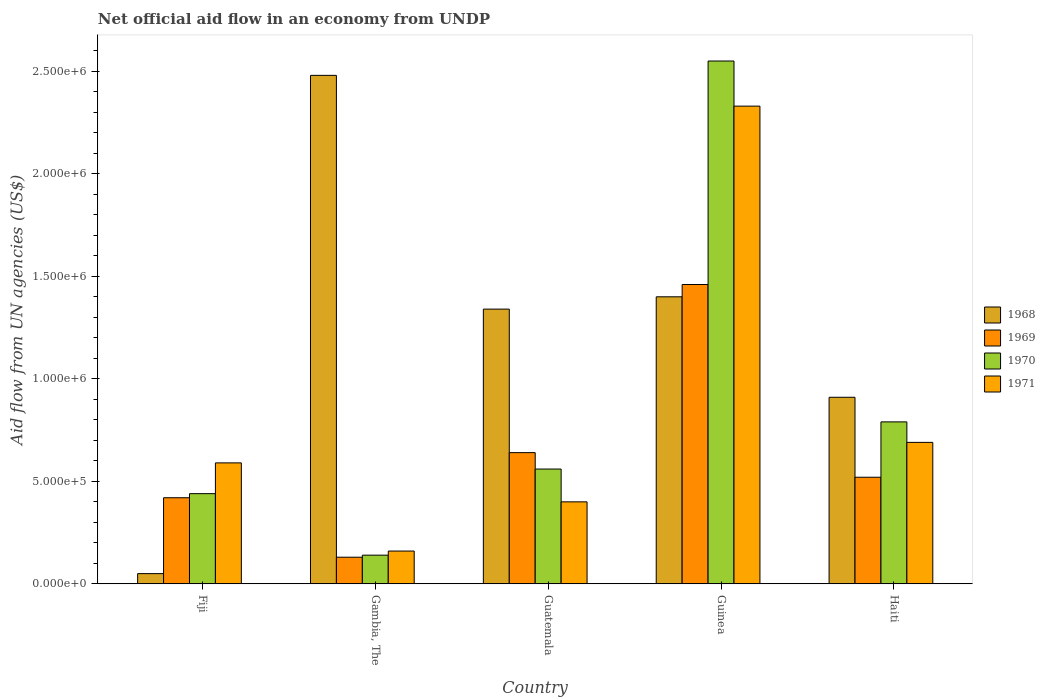How many different coloured bars are there?
Give a very brief answer. 4. How many groups of bars are there?
Provide a succinct answer. 5. Are the number of bars on each tick of the X-axis equal?
Your answer should be compact. Yes. What is the label of the 4th group of bars from the left?
Your response must be concise. Guinea. In how many cases, is the number of bars for a given country not equal to the number of legend labels?
Your answer should be compact. 0. What is the net official aid flow in 1969 in Haiti?
Provide a short and direct response. 5.20e+05. Across all countries, what is the maximum net official aid flow in 1969?
Your answer should be compact. 1.46e+06. Across all countries, what is the minimum net official aid flow in 1970?
Make the answer very short. 1.40e+05. In which country was the net official aid flow in 1971 maximum?
Your answer should be very brief. Guinea. In which country was the net official aid flow in 1970 minimum?
Provide a succinct answer. Gambia, The. What is the total net official aid flow in 1970 in the graph?
Give a very brief answer. 4.48e+06. What is the difference between the net official aid flow in 1971 in Fiji and that in Gambia, The?
Ensure brevity in your answer.  4.30e+05. What is the difference between the net official aid flow in 1970 in Guatemala and the net official aid flow in 1971 in Guinea?
Provide a short and direct response. -1.77e+06. What is the average net official aid flow in 1969 per country?
Your response must be concise. 6.34e+05. What is the difference between the net official aid flow of/in 1971 and net official aid flow of/in 1968 in Guinea?
Offer a very short reply. 9.30e+05. What is the ratio of the net official aid flow in 1971 in Gambia, The to that in Guatemala?
Provide a short and direct response. 0.4. What is the difference between the highest and the second highest net official aid flow in 1969?
Make the answer very short. 8.20e+05. What is the difference between the highest and the lowest net official aid flow in 1970?
Provide a short and direct response. 2.41e+06. Is the sum of the net official aid flow in 1968 in Guatemala and Haiti greater than the maximum net official aid flow in 1971 across all countries?
Give a very brief answer. No. What does the 3rd bar from the left in Guinea represents?
Your answer should be compact. 1970. What does the 4th bar from the right in Gambia, The represents?
Make the answer very short. 1968. Is it the case that in every country, the sum of the net official aid flow in 1969 and net official aid flow in 1971 is greater than the net official aid flow in 1970?
Offer a very short reply. Yes. How many bars are there?
Ensure brevity in your answer.  20. Are all the bars in the graph horizontal?
Your answer should be very brief. No. What is the difference between two consecutive major ticks on the Y-axis?
Offer a terse response. 5.00e+05. Are the values on the major ticks of Y-axis written in scientific E-notation?
Keep it short and to the point. Yes. Does the graph contain grids?
Your answer should be very brief. No. Where does the legend appear in the graph?
Make the answer very short. Center right. How many legend labels are there?
Ensure brevity in your answer.  4. How are the legend labels stacked?
Give a very brief answer. Vertical. What is the title of the graph?
Your answer should be very brief. Net official aid flow in an economy from UNDP. Does "1986" appear as one of the legend labels in the graph?
Make the answer very short. No. What is the label or title of the X-axis?
Your response must be concise. Country. What is the label or title of the Y-axis?
Keep it short and to the point. Aid flow from UN agencies (US$). What is the Aid flow from UN agencies (US$) in 1971 in Fiji?
Your answer should be very brief. 5.90e+05. What is the Aid flow from UN agencies (US$) in 1968 in Gambia, The?
Offer a very short reply. 2.48e+06. What is the Aid flow from UN agencies (US$) in 1969 in Gambia, The?
Ensure brevity in your answer.  1.30e+05. What is the Aid flow from UN agencies (US$) of 1968 in Guatemala?
Provide a short and direct response. 1.34e+06. What is the Aid flow from UN agencies (US$) in 1969 in Guatemala?
Provide a short and direct response. 6.40e+05. What is the Aid flow from UN agencies (US$) in 1970 in Guatemala?
Provide a short and direct response. 5.60e+05. What is the Aid flow from UN agencies (US$) in 1968 in Guinea?
Offer a very short reply. 1.40e+06. What is the Aid flow from UN agencies (US$) in 1969 in Guinea?
Keep it short and to the point. 1.46e+06. What is the Aid flow from UN agencies (US$) in 1970 in Guinea?
Provide a succinct answer. 2.55e+06. What is the Aid flow from UN agencies (US$) of 1971 in Guinea?
Your answer should be very brief. 2.33e+06. What is the Aid flow from UN agencies (US$) of 1968 in Haiti?
Keep it short and to the point. 9.10e+05. What is the Aid flow from UN agencies (US$) of 1969 in Haiti?
Your response must be concise. 5.20e+05. What is the Aid flow from UN agencies (US$) of 1970 in Haiti?
Offer a terse response. 7.90e+05. What is the Aid flow from UN agencies (US$) in 1971 in Haiti?
Your response must be concise. 6.90e+05. Across all countries, what is the maximum Aid flow from UN agencies (US$) of 1968?
Give a very brief answer. 2.48e+06. Across all countries, what is the maximum Aid flow from UN agencies (US$) in 1969?
Ensure brevity in your answer.  1.46e+06. Across all countries, what is the maximum Aid flow from UN agencies (US$) in 1970?
Give a very brief answer. 2.55e+06. Across all countries, what is the maximum Aid flow from UN agencies (US$) in 1971?
Give a very brief answer. 2.33e+06. Across all countries, what is the minimum Aid flow from UN agencies (US$) in 1969?
Provide a succinct answer. 1.30e+05. Across all countries, what is the minimum Aid flow from UN agencies (US$) of 1970?
Provide a succinct answer. 1.40e+05. Across all countries, what is the minimum Aid flow from UN agencies (US$) in 1971?
Your response must be concise. 1.60e+05. What is the total Aid flow from UN agencies (US$) in 1968 in the graph?
Offer a terse response. 6.18e+06. What is the total Aid flow from UN agencies (US$) in 1969 in the graph?
Make the answer very short. 3.17e+06. What is the total Aid flow from UN agencies (US$) in 1970 in the graph?
Offer a terse response. 4.48e+06. What is the total Aid flow from UN agencies (US$) of 1971 in the graph?
Your response must be concise. 4.17e+06. What is the difference between the Aid flow from UN agencies (US$) in 1968 in Fiji and that in Gambia, The?
Offer a very short reply. -2.43e+06. What is the difference between the Aid flow from UN agencies (US$) in 1968 in Fiji and that in Guatemala?
Offer a very short reply. -1.29e+06. What is the difference between the Aid flow from UN agencies (US$) of 1970 in Fiji and that in Guatemala?
Provide a succinct answer. -1.20e+05. What is the difference between the Aid flow from UN agencies (US$) of 1968 in Fiji and that in Guinea?
Your answer should be very brief. -1.35e+06. What is the difference between the Aid flow from UN agencies (US$) in 1969 in Fiji and that in Guinea?
Your answer should be compact. -1.04e+06. What is the difference between the Aid flow from UN agencies (US$) in 1970 in Fiji and that in Guinea?
Provide a short and direct response. -2.11e+06. What is the difference between the Aid flow from UN agencies (US$) of 1971 in Fiji and that in Guinea?
Provide a short and direct response. -1.74e+06. What is the difference between the Aid flow from UN agencies (US$) of 1968 in Fiji and that in Haiti?
Ensure brevity in your answer.  -8.60e+05. What is the difference between the Aid flow from UN agencies (US$) in 1970 in Fiji and that in Haiti?
Give a very brief answer. -3.50e+05. What is the difference between the Aid flow from UN agencies (US$) of 1968 in Gambia, The and that in Guatemala?
Provide a short and direct response. 1.14e+06. What is the difference between the Aid flow from UN agencies (US$) of 1969 in Gambia, The and that in Guatemala?
Your answer should be compact. -5.10e+05. What is the difference between the Aid flow from UN agencies (US$) in 1970 in Gambia, The and that in Guatemala?
Make the answer very short. -4.20e+05. What is the difference between the Aid flow from UN agencies (US$) in 1971 in Gambia, The and that in Guatemala?
Offer a very short reply. -2.40e+05. What is the difference between the Aid flow from UN agencies (US$) in 1968 in Gambia, The and that in Guinea?
Your response must be concise. 1.08e+06. What is the difference between the Aid flow from UN agencies (US$) of 1969 in Gambia, The and that in Guinea?
Make the answer very short. -1.33e+06. What is the difference between the Aid flow from UN agencies (US$) of 1970 in Gambia, The and that in Guinea?
Make the answer very short. -2.41e+06. What is the difference between the Aid flow from UN agencies (US$) in 1971 in Gambia, The and that in Guinea?
Your answer should be compact. -2.17e+06. What is the difference between the Aid flow from UN agencies (US$) of 1968 in Gambia, The and that in Haiti?
Your response must be concise. 1.57e+06. What is the difference between the Aid flow from UN agencies (US$) of 1969 in Gambia, The and that in Haiti?
Make the answer very short. -3.90e+05. What is the difference between the Aid flow from UN agencies (US$) in 1970 in Gambia, The and that in Haiti?
Your answer should be very brief. -6.50e+05. What is the difference between the Aid flow from UN agencies (US$) in 1971 in Gambia, The and that in Haiti?
Keep it short and to the point. -5.30e+05. What is the difference between the Aid flow from UN agencies (US$) in 1969 in Guatemala and that in Guinea?
Your response must be concise. -8.20e+05. What is the difference between the Aid flow from UN agencies (US$) in 1970 in Guatemala and that in Guinea?
Your answer should be compact. -1.99e+06. What is the difference between the Aid flow from UN agencies (US$) in 1971 in Guatemala and that in Guinea?
Your answer should be very brief. -1.93e+06. What is the difference between the Aid flow from UN agencies (US$) in 1968 in Guatemala and that in Haiti?
Make the answer very short. 4.30e+05. What is the difference between the Aid flow from UN agencies (US$) of 1969 in Guatemala and that in Haiti?
Your response must be concise. 1.20e+05. What is the difference between the Aid flow from UN agencies (US$) of 1970 in Guatemala and that in Haiti?
Ensure brevity in your answer.  -2.30e+05. What is the difference between the Aid flow from UN agencies (US$) of 1971 in Guatemala and that in Haiti?
Give a very brief answer. -2.90e+05. What is the difference between the Aid flow from UN agencies (US$) of 1968 in Guinea and that in Haiti?
Keep it short and to the point. 4.90e+05. What is the difference between the Aid flow from UN agencies (US$) in 1969 in Guinea and that in Haiti?
Your answer should be very brief. 9.40e+05. What is the difference between the Aid flow from UN agencies (US$) of 1970 in Guinea and that in Haiti?
Your response must be concise. 1.76e+06. What is the difference between the Aid flow from UN agencies (US$) of 1971 in Guinea and that in Haiti?
Give a very brief answer. 1.64e+06. What is the difference between the Aid flow from UN agencies (US$) of 1968 in Fiji and the Aid flow from UN agencies (US$) of 1969 in Gambia, The?
Your answer should be compact. -8.00e+04. What is the difference between the Aid flow from UN agencies (US$) in 1968 in Fiji and the Aid flow from UN agencies (US$) in 1970 in Gambia, The?
Ensure brevity in your answer.  -9.00e+04. What is the difference between the Aid flow from UN agencies (US$) in 1968 in Fiji and the Aid flow from UN agencies (US$) in 1971 in Gambia, The?
Provide a succinct answer. -1.10e+05. What is the difference between the Aid flow from UN agencies (US$) of 1969 in Fiji and the Aid flow from UN agencies (US$) of 1971 in Gambia, The?
Make the answer very short. 2.60e+05. What is the difference between the Aid flow from UN agencies (US$) of 1970 in Fiji and the Aid flow from UN agencies (US$) of 1971 in Gambia, The?
Offer a terse response. 2.80e+05. What is the difference between the Aid flow from UN agencies (US$) in 1968 in Fiji and the Aid flow from UN agencies (US$) in 1969 in Guatemala?
Keep it short and to the point. -5.90e+05. What is the difference between the Aid flow from UN agencies (US$) in 1968 in Fiji and the Aid flow from UN agencies (US$) in 1970 in Guatemala?
Offer a terse response. -5.10e+05. What is the difference between the Aid flow from UN agencies (US$) of 1968 in Fiji and the Aid flow from UN agencies (US$) of 1971 in Guatemala?
Your response must be concise. -3.50e+05. What is the difference between the Aid flow from UN agencies (US$) in 1969 in Fiji and the Aid flow from UN agencies (US$) in 1971 in Guatemala?
Keep it short and to the point. 2.00e+04. What is the difference between the Aid flow from UN agencies (US$) in 1968 in Fiji and the Aid flow from UN agencies (US$) in 1969 in Guinea?
Your answer should be compact. -1.41e+06. What is the difference between the Aid flow from UN agencies (US$) of 1968 in Fiji and the Aid flow from UN agencies (US$) of 1970 in Guinea?
Your answer should be very brief. -2.50e+06. What is the difference between the Aid flow from UN agencies (US$) in 1968 in Fiji and the Aid flow from UN agencies (US$) in 1971 in Guinea?
Your answer should be compact. -2.28e+06. What is the difference between the Aid flow from UN agencies (US$) in 1969 in Fiji and the Aid flow from UN agencies (US$) in 1970 in Guinea?
Offer a terse response. -2.13e+06. What is the difference between the Aid flow from UN agencies (US$) of 1969 in Fiji and the Aid flow from UN agencies (US$) of 1971 in Guinea?
Provide a short and direct response. -1.91e+06. What is the difference between the Aid flow from UN agencies (US$) in 1970 in Fiji and the Aid flow from UN agencies (US$) in 1971 in Guinea?
Your answer should be very brief. -1.89e+06. What is the difference between the Aid flow from UN agencies (US$) of 1968 in Fiji and the Aid flow from UN agencies (US$) of 1969 in Haiti?
Your answer should be compact. -4.70e+05. What is the difference between the Aid flow from UN agencies (US$) in 1968 in Fiji and the Aid flow from UN agencies (US$) in 1970 in Haiti?
Your answer should be compact. -7.40e+05. What is the difference between the Aid flow from UN agencies (US$) of 1968 in Fiji and the Aid flow from UN agencies (US$) of 1971 in Haiti?
Your answer should be compact. -6.40e+05. What is the difference between the Aid flow from UN agencies (US$) of 1969 in Fiji and the Aid flow from UN agencies (US$) of 1970 in Haiti?
Provide a succinct answer. -3.70e+05. What is the difference between the Aid flow from UN agencies (US$) in 1969 in Fiji and the Aid flow from UN agencies (US$) in 1971 in Haiti?
Provide a succinct answer. -2.70e+05. What is the difference between the Aid flow from UN agencies (US$) in 1968 in Gambia, The and the Aid flow from UN agencies (US$) in 1969 in Guatemala?
Keep it short and to the point. 1.84e+06. What is the difference between the Aid flow from UN agencies (US$) in 1968 in Gambia, The and the Aid flow from UN agencies (US$) in 1970 in Guatemala?
Your response must be concise. 1.92e+06. What is the difference between the Aid flow from UN agencies (US$) in 1968 in Gambia, The and the Aid flow from UN agencies (US$) in 1971 in Guatemala?
Provide a succinct answer. 2.08e+06. What is the difference between the Aid flow from UN agencies (US$) in 1969 in Gambia, The and the Aid flow from UN agencies (US$) in 1970 in Guatemala?
Your answer should be very brief. -4.30e+05. What is the difference between the Aid flow from UN agencies (US$) in 1969 in Gambia, The and the Aid flow from UN agencies (US$) in 1971 in Guatemala?
Make the answer very short. -2.70e+05. What is the difference between the Aid flow from UN agencies (US$) in 1970 in Gambia, The and the Aid flow from UN agencies (US$) in 1971 in Guatemala?
Your response must be concise. -2.60e+05. What is the difference between the Aid flow from UN agencies (US$) of 1968 in Gambia, The and the Aid flow from UN agencies (US$) of 1969 in Guinea?
Keep it short and to the point. 1.02e+06. What is the difference between the Aid flow from UN agencies (US$) in 1968 in Gambia, The and the Aid flow from UN agencies (US$) in 1970 in Guinea?
Keep it short and to the point. -7.00e+04. What is the difference between the Aid flow from UN agencies (US$) in 1968 in Gambia, The and the Aid flow from UN agencies (US$) in 1971 in Guinea?
Keep it short and to the point. 1.50e+05. What is the difference between the Aid flow from UN agencies (US$) of 1969 in Gambia, The and the Aid flow from UN agencies (US$) of 1970 in Guinea?
Provide a short and direct response. -2.42e+06. What is the difference between the Aid flow from UN agencies (US$) of 1969 in Gambia, The and the Aid flow from UN agencies (US$) of 1971 in Guinea?
Make the answer very short. -2.20e+06. What is the difference between the Aid flow from UN agencies (US$) of 1970 in Gambia, The and the Aid flow from UN agencies (US$) of 1971 in Guinea?
Provide a short and direct response. -2.19e+06. What is the difference between the Aid flow from UN agencies (US$) in 1968 in Gambia, The and the Aid flow from UN agencies (US$) in 1969 in Haiti?
Make the answer very short. 1.96e+06. What is the difference between the Aid flow from UN agencies (US$) in 1968 in Gambia, The and the Aid flow from UN agencies (US$) in 1970 in Haiti?
Your answer should be very brief. 1.69e+06. What is the difference between the Aid flow from UN agencies (US$) of 1968 in Gambia, The and the Aid flow from UN agencies (US$) of 1971 in Haiti?
Provide a succinct answer. 1.79e+06. What is the difference between the Aid flow from UN agencies (US$) of 1969 in Gambia, The and the Aid flow from UN agencies (US$) of 1970 in Haiti?
Provide a short and direct response. -6.60e+05. What is the difference between the Aid flow from UN agencies (US$) in 1969 in Gambia, The and the Aid flow from UN agencies (US$) in 1971 in Haiti?
Offer a terse response. -5.60e+05. What is the difference between the Aid flow from UN agencies (US$) of 1970 in Gambia, The and the Aid flow from UN agencies (US$) of 1971 in Haiti?
Keep it short and to the point. -5.50e+05. What is the difference between the Aid flow from UN agencies (US$) in 1968 in Guatemala and the Aid flow from UN agencies (US$) in 1969 in Guinea?
Your answer should be compact. -1.20e+05. What is the difference between the Aid flow from UN agencies (US$) in 1968 in Guatemala and the Aid flow from UN agencies (US$) in 1970 in Guinea?
Your response must be concise. -1.21e+06. What is the difference between the Aid flow from UN agencies (US$) of 1968 in Guatemala and the Aid flow from UN agencies (US$) of 1971 in Guinea?
Ensure brevity in your answer.  -9.90e+05. What is the difference between the Aid flow from UN agencies (US$) in 1969 in Guatemala and the Aid flow from UN agencies (US$) in 1970 in Guinea?
Offer a terse response. -1.91e+06. What is the difference between the Aid flow from UN agencies (US$) of 1969 in Guatemala and the Aid flow from UN agencies (US$) of 1971 in Guinea?
Provide a succinct answer. -1.69e+06. What is the difference between the Aid flow from UN agencies (US$) in 1970 in Guatemala and the Aid flow from UN agencies (US$) in 1971 in Guinea?
Offer a terse response. -1.77e+06. What is the difference between the Aid flow from UN agencies (US$) in 1968 in Guatemala and the Aid flow from UN agencies (US$) in 1969 in Haiti?
Make the answer very short. 8.20e+05. What is the difference between the Aid flow from UN agencies (US$) in 1968 in Guatemala and the Aid flow from UN agencies (US$) in 1970 in Haiti?
Provide a succinct answer. 5.50e+05. What is the difference between the Aid flow from UN agencies (US$) of 1968 in Guatemala and the Aid flow from UN agencies (US$) of 1971 in Haiti?
Offer a terse response. 6.50e+05. What is the difference between the Aid flow from UN agencies (US$) of 1970 in Guatemala and the Aid flow from UN agencies (US$) of 1971 in Haiti?
Keep it short and to the point. -1.30e+05. What is the difference between the Aid flow from UN agencies (US$) of 1968 in Guinea and the Aid flow from UN agencies (US$) of 1969 in Haiti?
Your response must be concise. 8.80e+05. What is the difference between the Aid flow from UN agencies (US$) of 1968 in Guinea and the Aid flow from UN agencies (US$) of 1971 in Haiti?
Keep it short and to the point. 7.10e+05. What is the difference between the Aid flow from UN agencies (US$) of 1969 in Guinea and the Aid flow from UN agencies (US$) of 1970 in Haiti?
Offer a terse response. 6.70e+05. What is the difference between the Aid flow from UN agencies (US$) of 1969 in Guinea and the Aid flow from UN agencies (US$) of 1971 in Haiti?
Provide a short and direct response. 7.70e+05. What is the difference between the Aid flow from UN agencies (US$) in 1970 in Guinea and the Aid flow from UN agencies (US$) in 1971 in Haiti?
Keep it short and to the point. 1.86e+06. What is the average Aid flow from UN agencies (US$) in 1968 per country?
Offer a very short reply. 1.24e+06. What is the average Aid flow from UN agencies (US$) of 1969 per country?
Offer a terse response. 6.34e+05. What is the average Aid flow from UN agencies (US$) of 1970 per country?
Your answer should be very brief. 8.96e+05. What is the average Aid flow from UN agencies (US$) in 1971 per country?
Offer a very short reply. 8.34e+05. What is the difference between the Aid flow from UN agencies (US$) in 1968 and Aid flow from UN agencies (US$) in 1969 in Fiji?
Give a very brief answer. -3.70e+05. What is the difference between the Aid flow from UN agencies (US$) in 1968 and Aid flow from UN agencies (US$) in 1970 in Fiji?
Your answer should be very brief. -3.90e+05. What is the difference between the Aid flow from UN agencies (US$) in 1968 and Aid flow from UN agencies (US$) in 1971 in Fiji?
Provide a succinct answer. -5.40e+05. What is the difference between the Aid flow from UN agencies (US$) of 1969 and Aid flow from UN agencies (US$) of 1970 in Fiji?
Offer a terse response. -2.00e+04. What is the difference between the Aid flow from UN agencies (US$) of 1970 and Aid flow from UN agencies (US$) of 1971 in Fiji?
Your answer should be very brief. -1.50e+05. What is the difference between the Aid flow from UN agencies (US$) in 1968 and Aid flow from UN agencies (US$) in 1969 in Gambia, The?
Offer a very short reply. 2.35e+06. What is the difference between the Aid flow from UN agencies (US$) in 1968 and Aid flow from UN agencies (US$) in 1970 in Gambia, The?
Your answer should be very brief. 2.34e+06. What is the difference between the Aid flow from UN agencies (US$) of 1968 and Aid flow from UN agencies (US$) of 1971 in Gambia, The?
Offer a terse response. 2.32e+06. What is the difference between the Aid flow from UN agencies (US$) in 1969 and Aid flow from UN agencies (US$) in 1970 in Gambia, The?
Your answer should be compact. -10000. What is the difference between the Aid flow from UN agencies (US$) of 1969 and Aid flow from UN agencies (US$) of 1971 in Gambia, The?
Ensure brevity in your answer.  -3.00e+04. What is the difference between the Aid flow from UN agencies (US$) in 1968 and Aid flow from UN agencies (US$) in 1969 in Guatemala?
Your answer should be very brief. 7.00e+05. What is the difference between the Aid flow from UN agencies (US$) of 1968 and Aid flow from UN agencies (US$) of 1970 in Guatemala?
Offer a very short reply. 7.80e+05. What is the difference between the Aid flow from UN agencies (US$) of 1968 and Aid flow from UN agencies (US$) of 1971 in Guatemala?
Make the answer very short. 9.40e+05. What is the difference between the Aid flow from UN agencies (US$) of 1968 and Aid flow from UN agencies (US$) of 1969 in Guinea?
Ensure brevity in your answer.  -6.00e+04. What is the difference between the Aid flow from UN agencies (US$) of 1968 and Aid flow from UN agencies (US$) of 1970 in Guinea?
Make the answer very short. -1.15e+06. What is the difference between the Aid flow from UN agencies (US$) of 1968 and Aid flow from UN agencies (US$) of 1971 in Guinea?
Your answer should be very brief. -9.30e+05. What is the difference between the Aid flow from UN agencies (US$) of 1969 and Aid flow from UN agencies (US$) of 1970 in Guinea?
Offer a terse response. -1.09e+06. What is the difference between the Aid flow from UN agencies (US$) in 1969 and Aid flow from UN agencies (US$) in 1971 in Guinea?
Offer a very short reply. -8.70e+05. What is the difference between the Aid flow from UN agencies (US$) in 1970 and Aid flow from UN agencies (US$) in 1971 in Guinea?
Provide a short and direct response. 2.20e+05. What is the difference between the Aid flow from UN agencies (US$) of 1968 and Aid flow from UN agencies (US$) of 1969 in Haiti?
Provide a succinct answer. 3.90e+05. What is the difference between the Aid flow from UN agencies (US$) of 1968 and Aid flow from UN agencies (US$) of 1970 in Haiti?
Give a very brief answer. 1.20e+05. What is the difference between the Aid flow from UN agencies (US$) in 1968 and Aid flow from UN agencies (US$) in 1971 in Haiti?
Give a very brief answer. 2.20e+05. What is the difference between the Aid flow from UN agencies (US$) of 1969 and Aid flow from UN agencies (US$) of 1970 in Haiti?
Offer a very short reply. -2.70e+05. What is the difference between the Aid flow from UN agencies (US$) in 1969 and Aid flow from UN agencies (US$) in 1971 in Haiti?
Keep it short and to the point. -1.70e+05. What is the ratio of the Aid flow from UN agencies (US$) of 1968 in Fiji to that in Gambia, The?
Offer a terse response. 0.02. What is the ratio of the Aid flow from UN agencies (US$) of 1969 in Fiji to that in Gambia, The?
Provide a succinct answer. 3.23. What is the ratio of the Aid flow from UN agencies (US$) of 1970 in Fiji to that in Gambia, The?
Your response must be concise. 3.14. What is the ratio of the Aid flow from UN agencies (US$) of 1971 in Fiji to that in Gambia, The?
Your answer should be very brief. 3.69. What is the ratio of the Aid flow from UN agencies (US$) of 1968 in Fiji to that in Guatemala?
Keep it short and to the point. 0.04. What is the ratio of the Aid flow from UN agencies (US$) in 1969 in Fiji to that in Guatemala?
Ensure brevity in your answer.  0.66. What is the ratio of the Aid flow from UN agencies (US$) of 1970 in Fiji to that in Guatemala?
Your response must be concise. 0.79. What is the ratio of the Aid flow from UN agencies (US$) in 1971 in Fiji to that in Guatemala?
Make the answer very short. 1.48. What is the ratio of the Aid flow from UN agencies (US$) in 1968 in Fiji to that in Guinea?
Provide a short and direct response. 0.04. What is the ratio of the Aid flow from UN agencies (US$) of 1969 in Fiji to that in Guinea?
Your answer should be compact. 0.29. What is the ratio of the Aid flow from UN agencies (US$) in 1970 in Fiji to that in Guinea?
Provide a short and direct response. 0.17. What is the ratio of the Aid flow from UN agencies (US$) in 1971 in Fiji to that in Guinea?
Provide a succinct answer. 0.25. What is the ratio of the Aid flow from UN agencies (US$) of 1968 in Fiji to that in Haiti?
Make the answer very short. 0.05. What is the ratio of the Aid flow from UN agencies (US$) in 1969 in Fiji to that in Haiti?
Make the answer very short. 0.81. What is the ratio of the Aid flow from UN agencies (US$) of 1970 in Fiji to that in Haiti?
Keep it short and to the point. 0.56. What is the ratio of the Aid flow from UN agencies (US$) in 1971 in Fiji to that in Haiti?
Ensure brevity in your answer.  0.86. What is the ratio of the Aid flow from UN agencies (US$) of 1968 in Gambia, The to that in Guatemala?
Give a very brief answer. 1.85. What is the ratio of the Aid flow from UN agencies (US$) in 1969 in Gambia, The to that in Guatemala?
Make the answer very short. 0.2. What is the ratio of the Aid flow from UN agencies (US$) of 1970 in Gambia, The to that in Guatemala?
Keep it short and to the point. 0.25. What is the ratio of the Aid flow from UN agencies (US$) in 1968 in Gambia, The to that in Guinea?
Offer a terse response. 1.77. What is the ratio of the Aid flow from UN agencies (US$) of 1969 in Gambia, The to that in Guinea?
Ensure brevity in your answer.  0.09. What is the ratio of the Aid flow from UN agencies (US$) in 1970 in Gambia, The to that in Guinea?
Ensure brevity in your answer.  0.05. What is the ratio of the Aid flow from UN agencies (US$) in 1971 in Gambia, The to that in Guinea?
Your answer should be compact. 0.07. What is the ratio of the Aid flow from UN agencies (US$) in 1968 in Gambia, The to that in Haiti?
Your response must be concise. 2.73. What is the ratio of the Aid flow from UN agencies (US$) of 1970 in Gambia, The to that in Haiti?
Ensure brevity in your answer.  0.18. What is the ratio of the Aid flow from UN agencies (US$) of 1971 in Gambia, The to that in Haiti?
Keep it short and to the point. 0.23. What is the ratio of the Aid flow from UN agencies (US$) of 1968 in Guatemala to that in Guinea?
Give a very brief answer. 0.96. What is the ratio of the Aid flow from UN agencies (US$) of 1969 in Guatemala to that in Guinea?
Provide a short and direct response. 0.44. What is the ratio of the Aid flow from UN agencies (US$) of 1970 in Guatemala to that in Guinea?
Offer a very short reply. 0.22. What is the ratio of the Aid flow from UN agencies (US$) in 1971 in Guatemala to that in Guinea?
Your answer should be very brief. 0.17. What is the ratio of the Aid flow from UN agencies (US$) in 1968 in Guatemala to that in Haiti?
Your response must be concise. 1.47. What is the ratio of the Aid flow from UN agencies (US$) in 1969 in Guatemala to that in Haiti?
Your answer should be very brief. 1.23. What is the ratio of the Aid flow from UN agencies (US$) of 1970 in Guatemala to that in Haiti?
Your answer should be compact. 0.71. What is the ratio of the Aid flow from UN agencies (US$) in 1971 in Guatemala to that in Haiti?
Your answer should be very brief. 0.58. What is the ratio of the Aid flow from UN agencies (US$) of 1968 in Guinea to that in Haiti?
Provide a succinct answer. 1.54. What is the ratio of the Aid flow from UN agencies (US$) of 1969 in Guinea to that in Haiti?
Keep it short and to the point. 2.81. What is the ratio of the Aid flow from UN agencies (US$) in 1970 in Guinea to that in Haiti?
Your response must be concise. 3.23. What is the ratio of the Aid flow from UN agencies (US$) in 1971 in Guinea to that in Haiti?
Offer a terse response. 3.38. What is the difference between the highest and the second highest Aid flow from UN agencies (US$) of 1968?
Your answer should be very brief. 1.08e+06. What is the difference between the highest and the second highest Aid flow from UN agencies (US$) in 1969?
Your answer should be compact. 8.20e+05. What is the difference between the highest and the second highest Aid flow from UN agencies (US$) of 1970?
Provide a short and direct response. 1.76e+06. What is the difference between the highest and the second highest Aid flow from UN agencies (US$) in 1971?
Your answer should be compact. 1.64e+06. What is the difference between the highest and the lowest Aid flow from UN agencies (US$) in 1968?
Keep it short and to the point. 2.43e+06. What is the difference between the highest and the lowest Aid flow from UN agencies (US$) of 1969?
Provide a succinct answer. 1.33e+06. What is the difference between the highest and the lowest Aid flow from UN agencies (US$) in 1970?
Keep it short and to the point. 2.41e+06. What is the difference between the highest and the lowest Aid flow from UN agencies (US$) of 1971?
Give a very brief answer. 2.17e+06. 